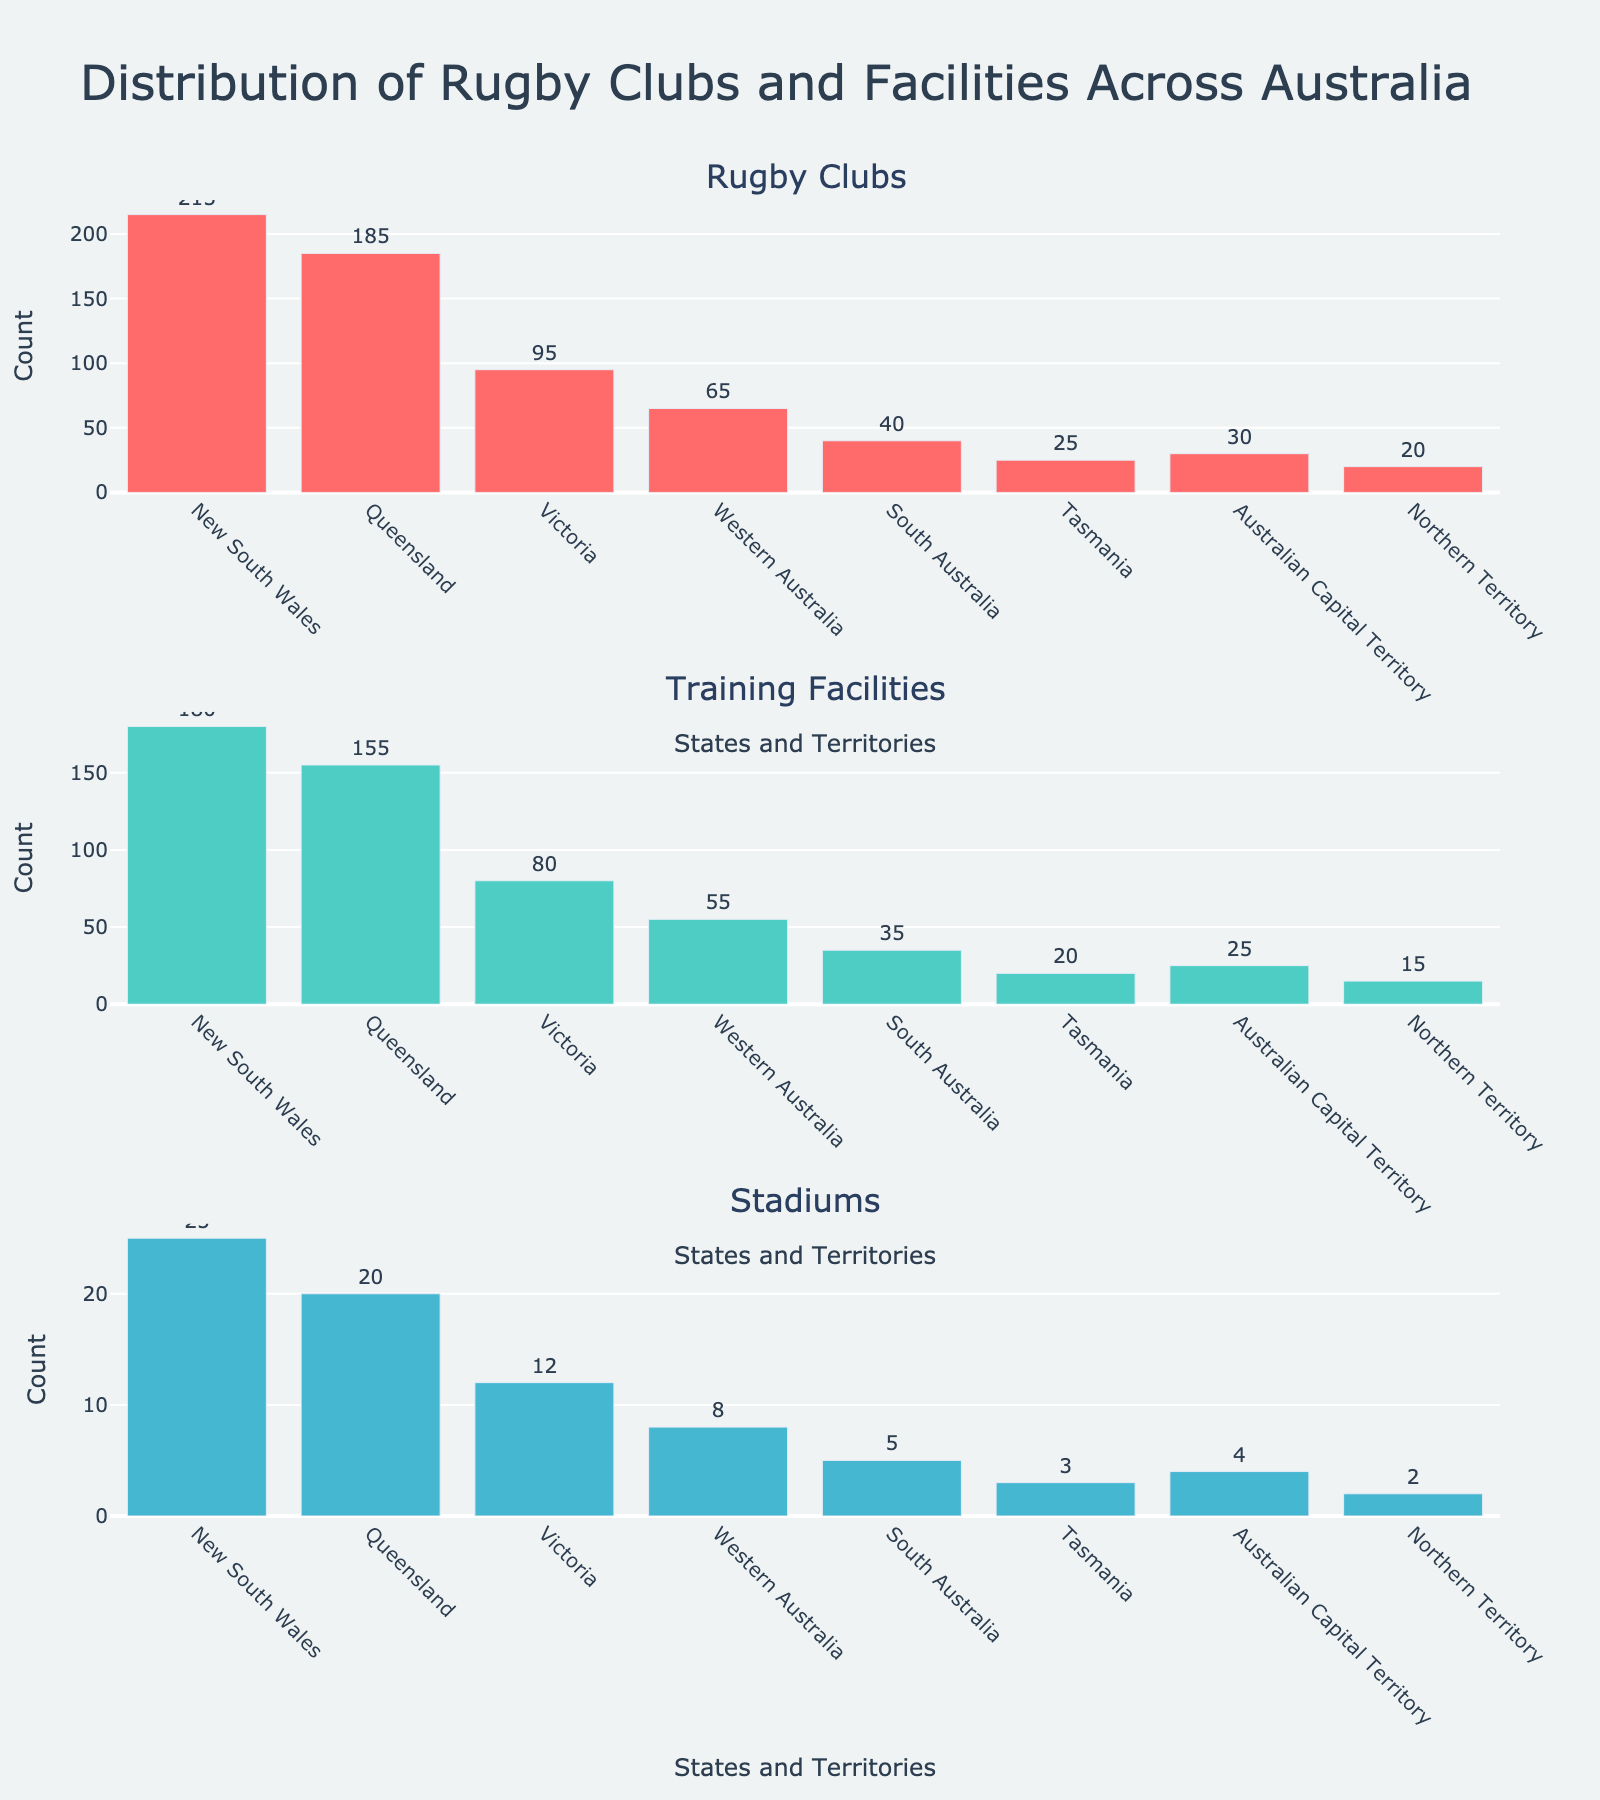How many activities are tracked in the figure? The subplot figure has titles for each activity, which include Soccer, Swimming, Piano, Art, and Dance. Counting these titles shows there are five activities.
Answer: Five Which season has the highest participation in Swimming? Looking at the Swimming subplot, the bar for Summer is the highest, indicating the highest participation.
Answer: Summer What is the total participation for Piano across all seasons? Adding up the Piano participation values: Fall (30) + Winter (35) + Spring (25) + Summer (15) = 105
Answer: 105 Which activity had the lowest participation in Winter? In the Winter subplot, Soccer shows the lowest value of 10, compared to Swimming (35), Piano (35), Art (30), and Dance (20).
Answer: Soccer Compare the participation in Dance during Fall and Spring. Which season had higher participation? The Dance participation in Fall is 15, and in Spring, it is 30. Comparing these values, Spring has higher participation.
Answer: Spring How does the participation in Art change from Summer to Fall? In the Art subplot, the bar value for Summer is 35, and for Fall is 25. The participation decreases by 10 when moving from Summer to Fall.
Answer: Decreases by 10 What's the average participation for Soccer across all seasons? The total participation for Soccer is Fall (45) + Winter (10) + Spring (40) + Summer (30) = 125. The average is 125/4 = 31.25.
Answer: 31.25 Which activity has the most variation in participation depending on the season? By comparing the heights of the bars in each subplot, it is observed that Soccer has the most variation with the highest peaks and lowest troughs, varying from 10 (Winter) to 45 (Fall).
Answer: Soccer In which season is Dance participation at its peak? In the Dance subplot, the highest bar is for Spring, where the participation is 30.
Answer: Spring 